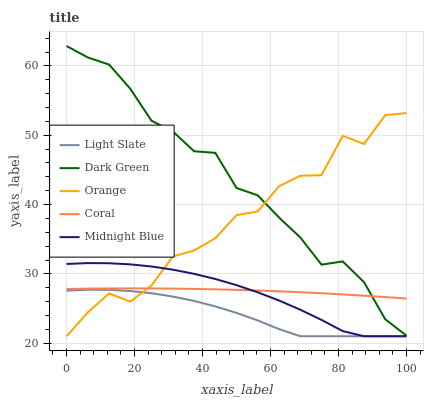Does Light Slate have the minimum area under the curve?
Answer yes or no. Yes. Does Dark Green have the maximum area under the curve?
Answer yes or no. Yes. Does Orange have the minimum area under the curve?
Answer yes or no. No. Does Orange have the maximum area under the curve?
Answer yes or no. No. Is Coral the smoothest?
Answer yes or no. Yes. Is Orange the roughest?
Answer yes or no. Yes. Is Orange the smoothest?
Answer yes or no. No. Is Coral the roughest?
Answer yes or no. No. Does Light Slate have the lowest value?
Answer yes or no. Yes. Does Coral have the lowest value?
Answer yes or no. No. Does Dark Green have the highest value?
Answer yes or no. Yes. Does Orange have the highest value?
Answer yes or no. No. Is Light Slate less than Dark Green?
Answer yes or no. Yes. Is Dark Green greater than Light Slate?
Answer yes or no. Yes. Does Midnight Blue intersect Light Slate?
Answer yes or no. Yes. Is Midnight Blue less than Light Slate?
Answer yes or no. No. Is Midnight Blue greater than Light Slate?
Answer yes or no. No. Does Light Slate intersect Dark Green?
Answer yes or no. No. 